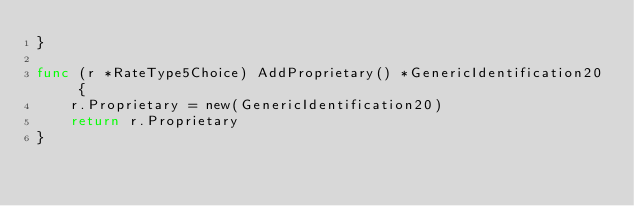<code> <loc_0><loc_0><loc_500><loc_500><_Go_>}

func (r *RateType5Choice) AddProprietary() *GenericIdentification20 {
	r.Proprietary = new(GenericIdentification20)
	return r.Proprietary
}

</code> 